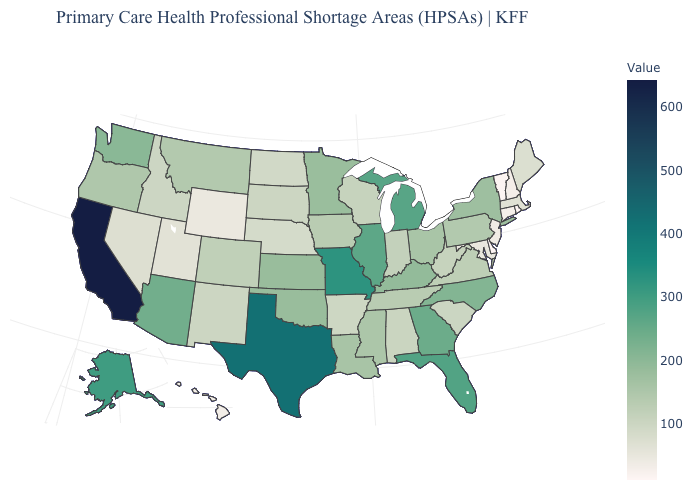Does Washington have the lowest value in the USA?
Answer briefly. No. Which states have the lowest value in the USA?
Be succinct. Delaware. Is the legend a continuous bar?
Answer briefly. Yes. Which states have the highest value in the USA?
Be succinct. California. Does Delaware have the lowest value in the USA?
Give a very brief answer. Yes. 